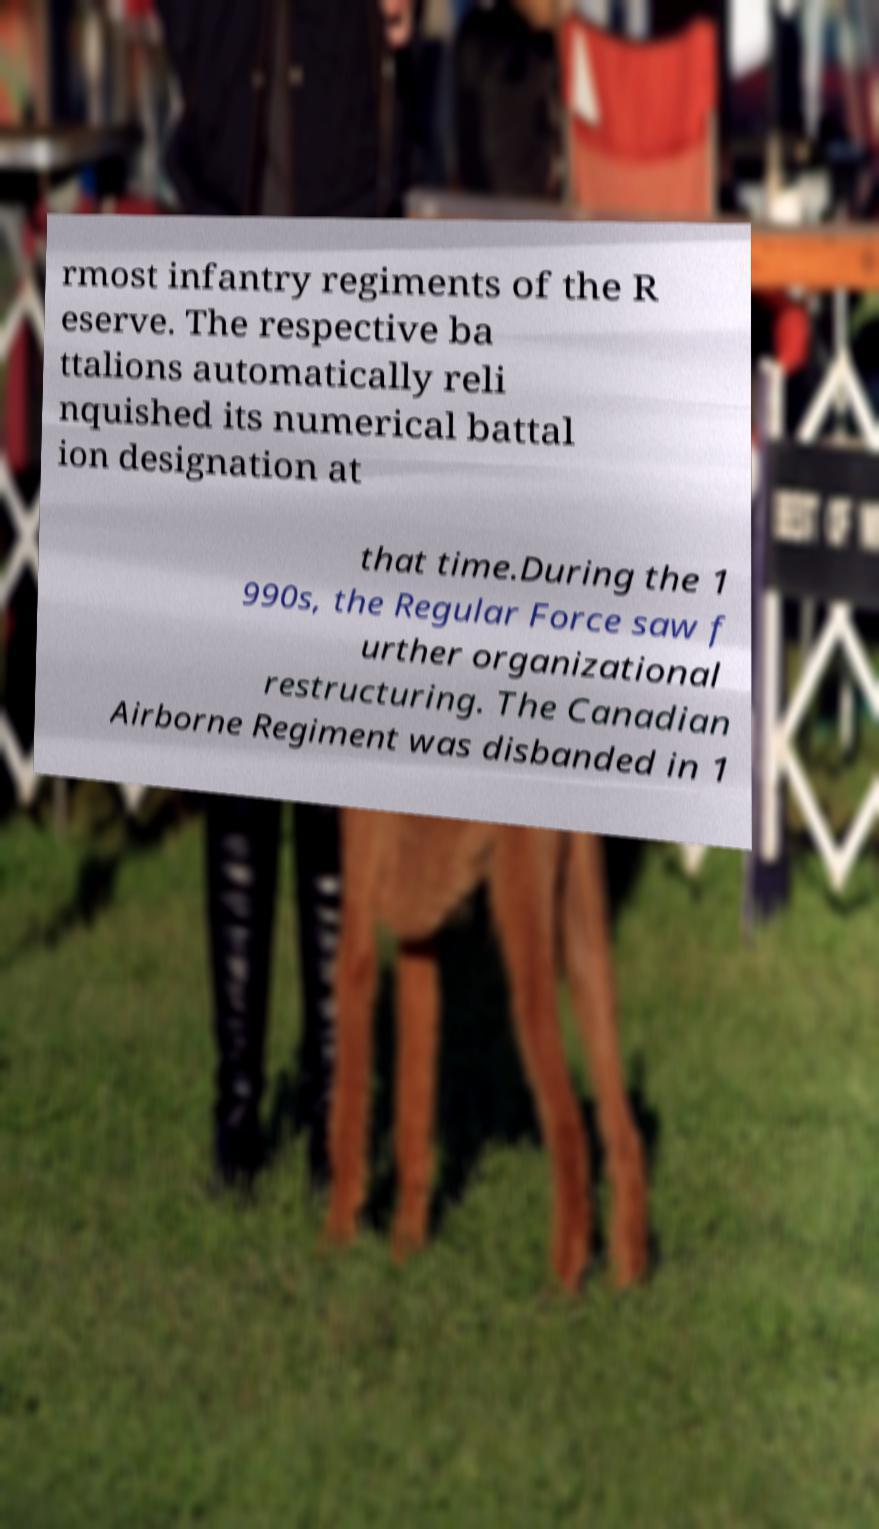Could you extract and type out the text from this image? rmost infantry regiments of the R eserve. The respective ba ttalions automatically reli nquished its numerical battal ion designation at that time.During the 1 990s, the Regular Force saw f urther organizational restructuring. The Canadian Airborne Regiment was disbanded in 1 